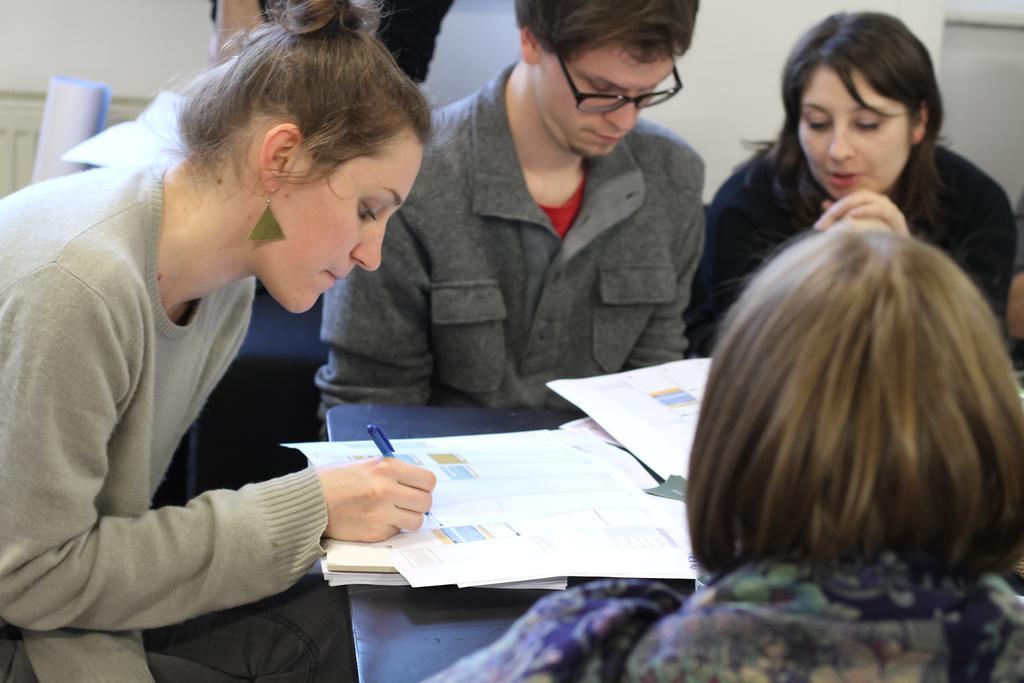In one or two sentences, can you explain what this image depicts? This picture show about a woman wearing a grey color t-shirt sitting on the chair and writing something on the paper. Beside there is a boy wearing grey t-shirt sitting and looking into the paper. On the right side there are two girls who are looking to them. In the background there is a white color wall. 